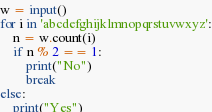<code> <loc_0><loc_0><loc_500><loc_500><_Python_>w = input()
for i in 'abcdefghijklmnopqrstuvwxyz':
    n = w.count(i)
    if n % 2 == 1:
        print("No")
        break
else:
    print("Yes")
</code> 